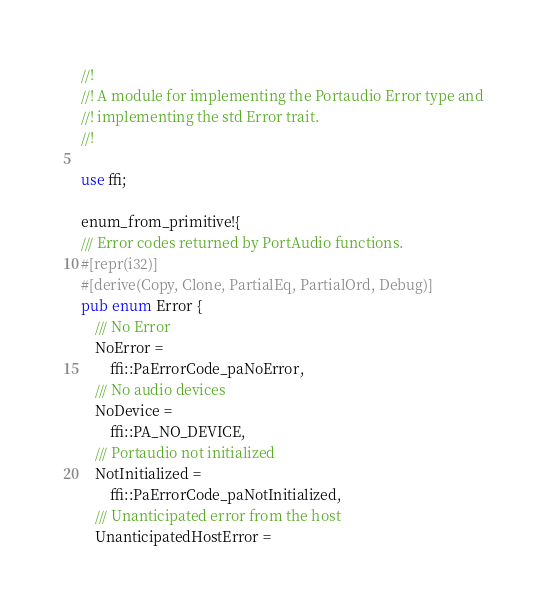<code> <loc_0><loc_0><loc_500><loc_500><_Rust_>//!
//! A module for implementing the Portaudio Error type and
//! implementing the std Error trait.
//!

use ffi;

enum_from_primitive!{
/// Error codes returned by PortAudio functions.
#[repr(i32)]
#[derive(Copy, Clone, PartialEq, PartialOrd, Debug)]
pub enum Error {
    /// No Error
    NoError =
        ffi::PaErrorCode_paNoError,
    /// No audio devices
    NoDevice =
        ffi::PA_NO_DEVICE,
    /// Portaudio not initialized
    NotInitialized =
        ffi::PaErrorCode_paNotInitialized,
    /// Unanticipated error from the host
    UnanticipatedHostError =</code> 